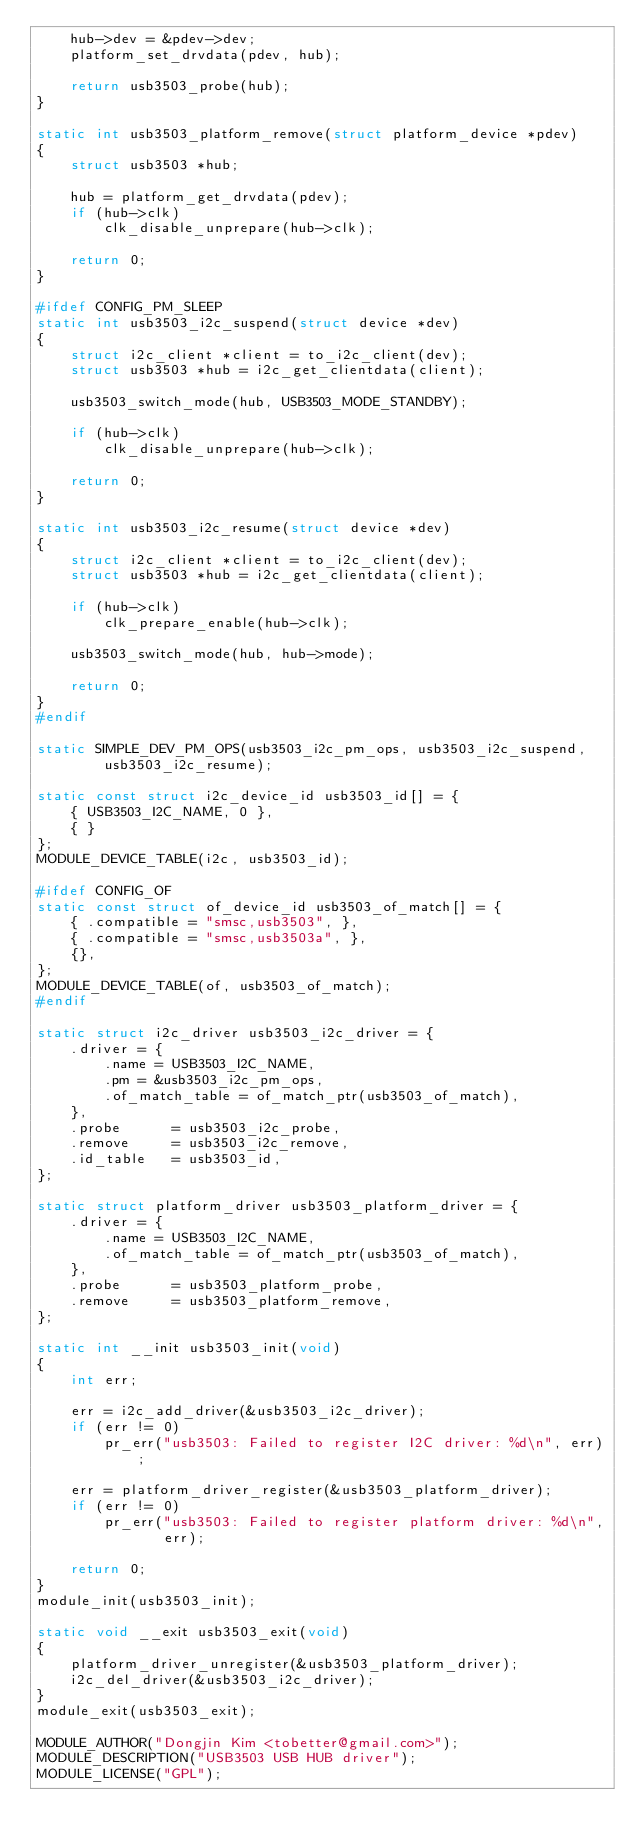<code> <loc_0><loc_0><loc_500><loc_500><_C_>	hub->dev = &pdev->dev;
	platform_set_drvdata(pdev, hub);

	return usb3503_probe(hub);
}

static int usb3503_platform_remove(struct platform_device *pdev)
{
	struct usb3503 *hub;

	hub = platform_get_drvdata(pdev);
	if (hub->clk)
		clk_disable_unprepare(hub->clk);

	return 0;
}

#ifdef CONFIG_PM_SLEEP
static int usb3503_i2c_suspend(struct device *dev)
{
	struct i2c_client *client = to_i2c_client(dev);
	struct usb3503 *hub = i2c_get_clientdata(client);

	usb3503_switch_mode(hub, USB3503_MODE_STANDBY);

	if (hub->clk)
		clk_disable_unprepare(hub->clk);

	return 0;
}

static int usb3503_i2c_resume(struct device *dev)
{
	struct i2c_client *client = to_i2c_client(dev);
	struct usb3503 *hub = i2c_get_clientdata(client);

	if (hub->clk)
		clk_prepare_enable(hub->clk);

	usb3503_switch_mode(hub, hub->mode);

	return 0;
}
#endif

static SIMPLE_DEV_PM_OPS(usb3503_i2c_pm_ops, usb3503_i2c_suspend,
		usb3503_i2c_resume);

static const struct i2c_device_id usb3503_id[] = {
	{ USB3503_I2C_NAME, 0 },
	{ }
};
MODULE_DEVICE_TABLE(i2c, usb3503_id);

#ifdef CONFIG_OF
static const struct of_device_id usb3503_of_match[] = {
	{ .compatible = "smsc,usb3503", },
	{ .compatible = "smsc,usb3503a", },
	{},
};
MODULE_DEVICE_TABLE(of, usb3503_of_match);
#endif

static struct i2c_driver usb3503_i2c_driver = {
	.driver = {
		.name = USB3503_I2C_NAME,
		.pm = &usb3503_i2c_pm_ops,
		.of_match_table = of_match_ptr(usb3503_of_match),
	},
	.probe		= usb3503_i2c_probe,
	.remove		= usb3503_i2c_remove,
	.id_table	= usb3503_id,
};

static struct platform_driver usb3503_platform_driver = {
	.driver = {
		.name = USB3503_I2C_NAME,
		.of_match_table = of_match_ptr(usb3503_of_match),
	},
	.probe		= usb3503_platform_probe,
	.remove		= usb3503_platform_remove,
};

static int __init usb3503_init(void)
{
	int err;

	err = i2c_add_driver(&usb3503_i2c_driver);
	if (err != 0)
		pr_err("usb3503: Failed to register I2C driver: %d\n", err);

	err = platform_driver_register(&usb3503_platform_driver);
	if (err != 0)
		pr_err("usb3503: Failed to register platform driver: %d\n",
		       err);

	return 0;
}
module_init(usb3503_init);

static void __exit usb3503_exit(void)
{
	platform_driver_unregister(&usb3503_platform_driver);
	i2c_del_driver(&usb3503_i2c_driver);
}
module_exit(usb3503_exit);

MODULE_AUTHOR("Dongjin Kim <tobetter@gmail.com>");
MODULE_DESCRIPTION("USB3503 USB HUB driver");
MODULE_LICENSE("GPL");
</code> 